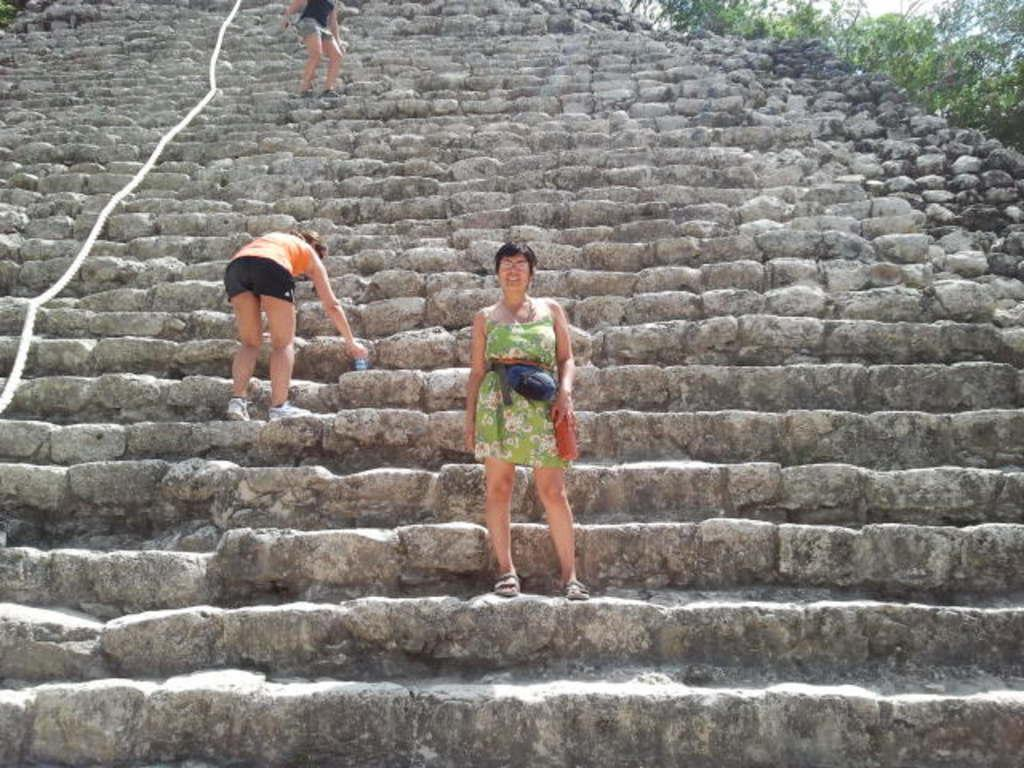What are the people in the image doing? The persons in the image are standing on the stairs. What object can be seen in the image besides the stairs and people? There is a rope visible in the image. What can be seen in the background of the image? Sky and plants are visible in the background of the image. What type of pickle is being used to decorate the stairs in the image? There is no pickle present in the image, as it is a picture of people standing on stairs with a rope and a background of sky and plants. 